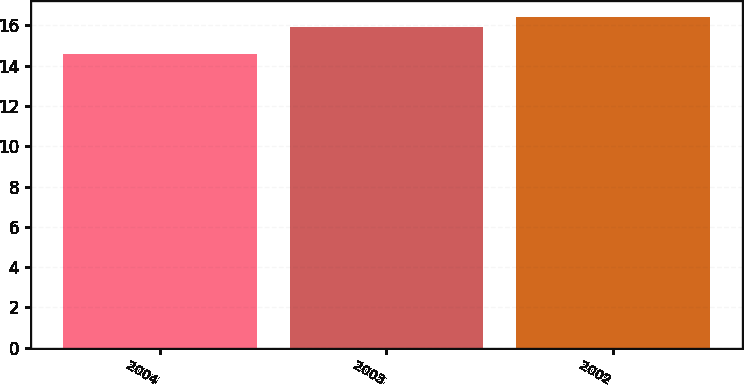Convert chart. <chart><loc_0><loc_0><loc_500><loc_500><bar_chart><fcel>2004<fcel>2003<fcel>2002<nl><fcel>14.6<fcel>15.9<fcel>16.4<nl></chart> 